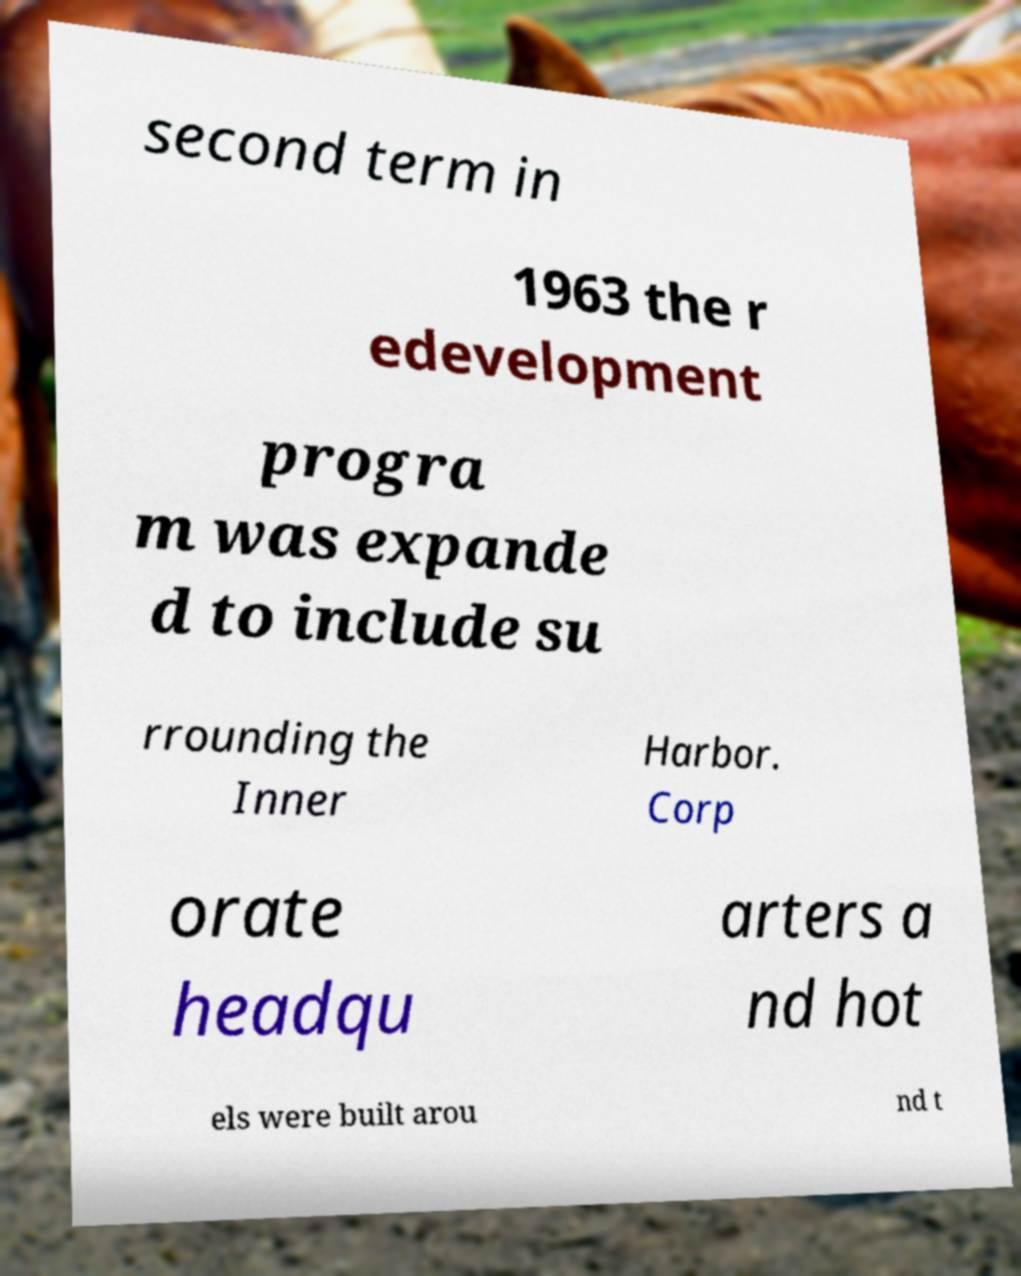Can you read and provide the text displayed in the image?This photo seems to have some interesting text. Can you extract and type it out for me? second term in 1963 the r edevelopment progra m was expande d to include su rrounding the Inner Harbor. Corp orate headqu arters a nd hot els were built arou nd t 